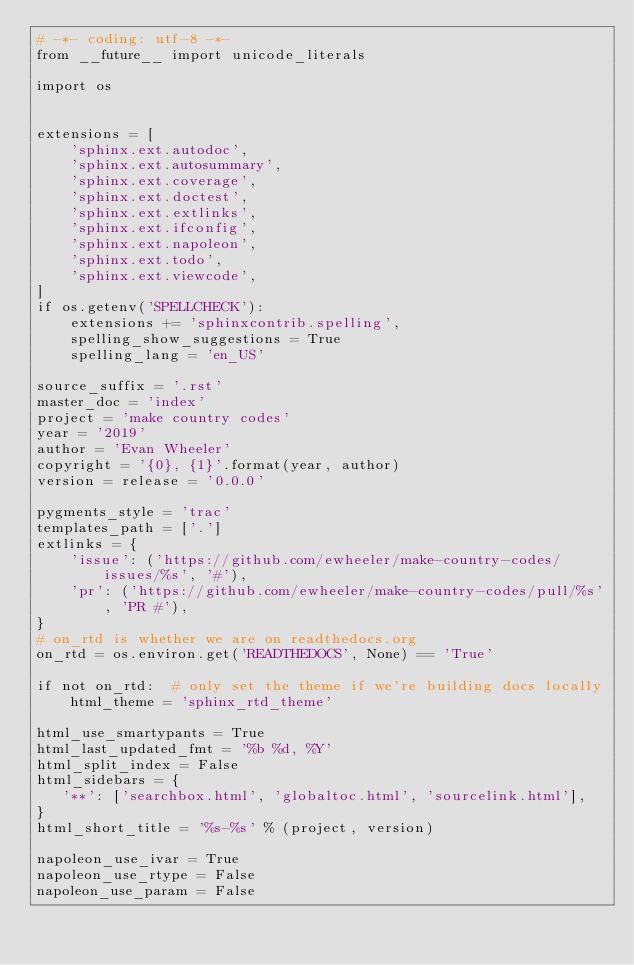Convert code to text. <code><loc_0><loc_0><loc_500><loc_500><_Python_># -*- coding: utf-8 -*-
from __future__ import unicode_literals

import os


extensions = [
    'sphinx.ext.autodoc',
    'sphinx.ext.autosummary',
    'sphinx.ext.coverage',
    'sphinx.ext.doctest',
    'sphinx.ext.extlinks',
    'sphinx.ext.ifconfig',
    'sphinx.ext.napoleon',
    'sphinx.ext.todo',
    'sphinx.ext.viewcode',
]
if os.getenv('SPELLCHECK'):
    extensions += 'sphinxcontrib.spelling',
    spelling_show_suggestions = True
    spelling_lang = 'en_US'

source_suffix = '.rst'
master_doc = 'index'
project = 'make country codes'
year = '2019'
author = 'Evan Wheeler'
copyright = '{0}, {1}'.format(year, author)
version = release = '0.0.0'

pygments_style = 'trac'
templates_path = ['.']
extlinks = {
    'issue': ('https://github.com/ewheeler/make-country-codes/issues/%s', '#'),
    'pr': ('https://github.com/ewheeler/make-country-codes/pull/%s', 'PR #'),
}
# on_rtd is whether we are on readthedocs.org
on_rtd = os.environ.get('READTHEDOCS', None) == 'True'

if not on_rtd:  # only set the theme if we're building docs locally
    html_theme = 'sphinx_rtd_theme'

html_use_smartypants = True
html_last_updated_fmt = '%b %d, %Y'
html_split_index = False
html_sidebars = {
   '**': ['searchbox.html', 'globaltoc.html', 'sourcelink.html'],
}
html_short_title = '%s-%s' % (project, version)

napoleon_use_ivar = True
napoleon_use_rtype = False
napoleon_use_param = False
</code> 